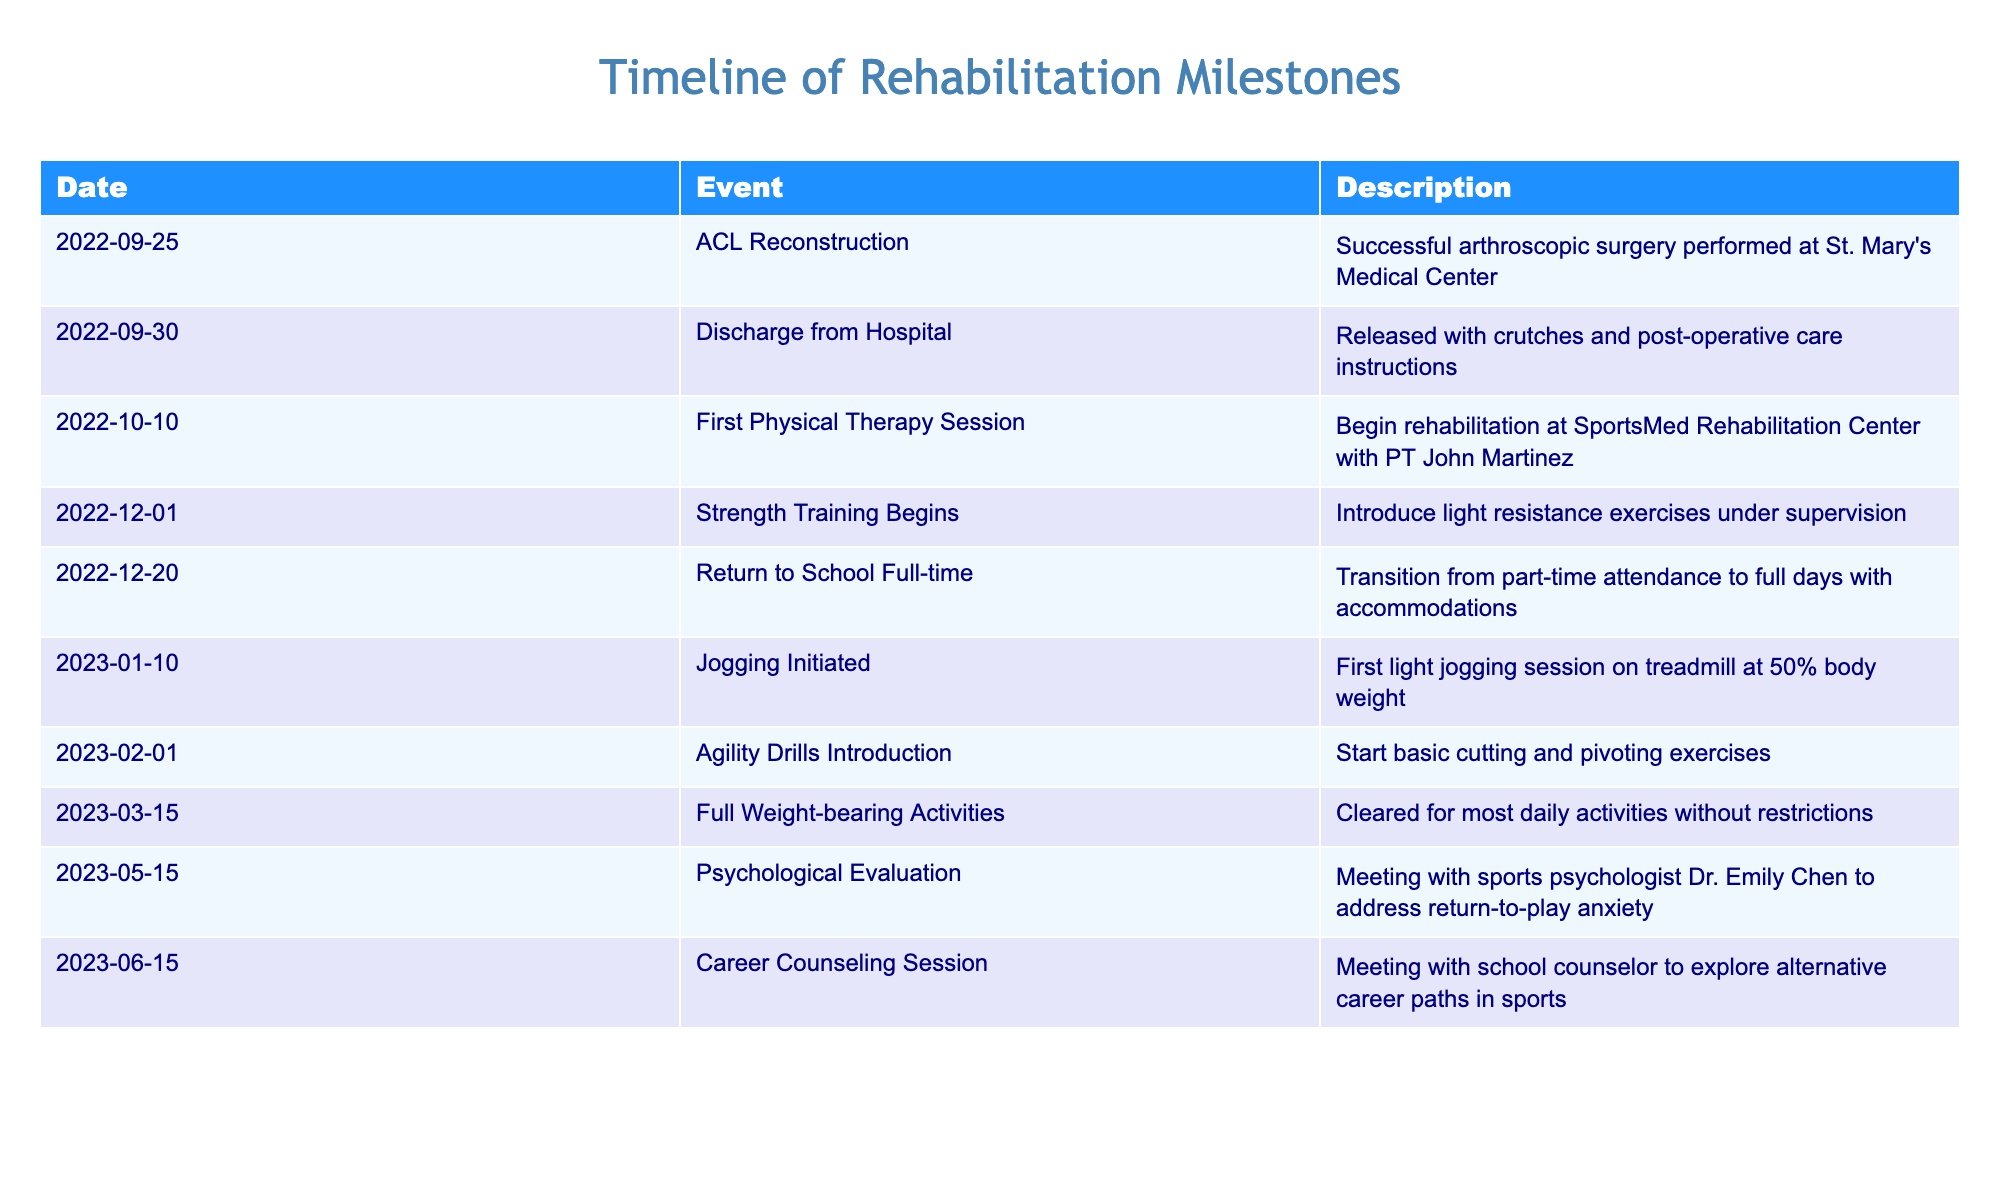What was the date of the ACL reconstruction surgery? The table lists the event "ACL Reconstruction" with the date provided. Simply read the date associated with that event. The date shown is 2022-09-25.
Answer: 2022-09-25 How many days passed between the ACL reconstruction and hospital discharge? The ACL reconstruction occurred on 2022-09-25 and discharge from the hospital followed on 2022-09-30. Counting the days, we find: 30 - 25 = 5 days.
Answer: 5 days What was introduced at the strength training milestone on December 1, 2022? The description under the strength training milestone states that "light resistance exercises" were introduced. This information can be directly retrieved from the table.
Answer: Light resistance exercises Did a psychological evaluation occur before the start of jogging? The psychological evaluation is noted on 2023-05-15, while jogging began on 2023-01-10. Since May comes after January, the evaluation did occur after jogging initiated. Thus, the answer is "No."
Answer: No What are the two primary milestones that occurred in May 2023? The table indicates that on May 15, 2023, there was a psychological evaluation and the session of career counseling on June 15, 2023. Since only one event is listed in May, there is only the psychological evaluation as the primary milestone in that month.
Answer: Psychological evaluation Which event was the final step in the reported rehabilitation milestones? A close inspection of the table reveals that the most recent event listed is the career counseling session on June 15, 2023. This is the last milestone in the timeline.
Answer: Career counseling session Was there a physical therapy session before strength training began? The first physical therapy session occurred on October 10, 2022, while strength training began later on December 1, 2022. Since October comes before December, the therapy session indeed occurred first.
Answer: Yes Calculate the duration, in months, from surgery to returning to full-time school. The ACL reconstruction was on September 25, 2022, and returning to school full-time occurred on December 20, 2022. Breaking this down: from September 25 to October 25 is 1 month; from October 25 to November 25 is another month; and from November 25 to December 20 is about 3 weeks. In total, this is approximately 2 months and 3 weeks, which means the duration is about 2.75 months.
Answer: Approximately 2.75 months 